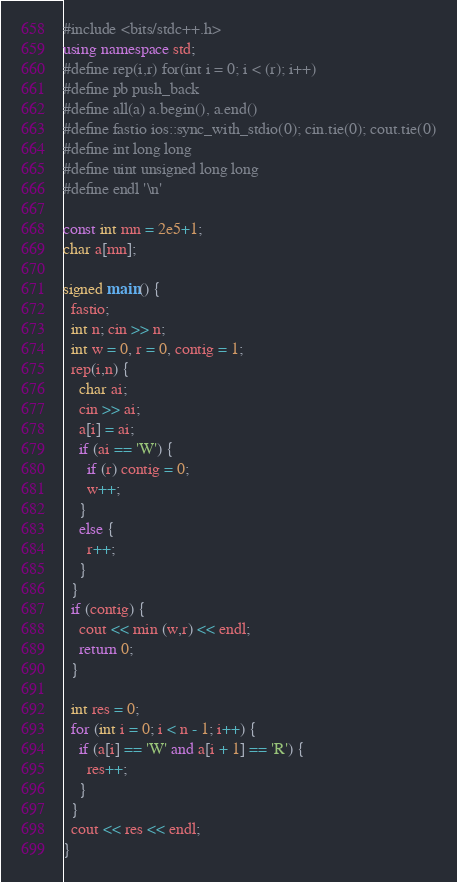<code> <loc_0><loc_0><loc_500><loc_500><_C++_>#include <bits/stdc++.h>
using namespace std;
#define rep(i,r) for(int i = 0; i < (r); i++)
#define pb push_back
#define all(a) a.begin(), a.end()
#define fastio ios::sync_with_stdio(0); cin.tie(0); cout.tie(0)
#define int long long
#define uint unsigned long long
#define endl '\n'

const int mn = 2e5+1;
char a[mn];

signed main() {
  fastio;
  int n; cin >> n;
  int w = 0, r = 0, contig = 1;
  rep(i,n) {
    char ai;
    cin >> ai;
    a[i] = ai;
    if (ai == 'W') {
      if (r) contig = 0;
      w++;
    }
    else {
      r++;
    }
  }
  if (contig) {
    cout << min (w,r) << endl;
    return 0;
  }

  int res = 0;
  for (int i = 0; i < n - 1; i++) {
    if (a[i] == 'W' and a[i + 1] == 'R') {
      res++;
    }
  }
  cout << res << endl;
}
</code> 